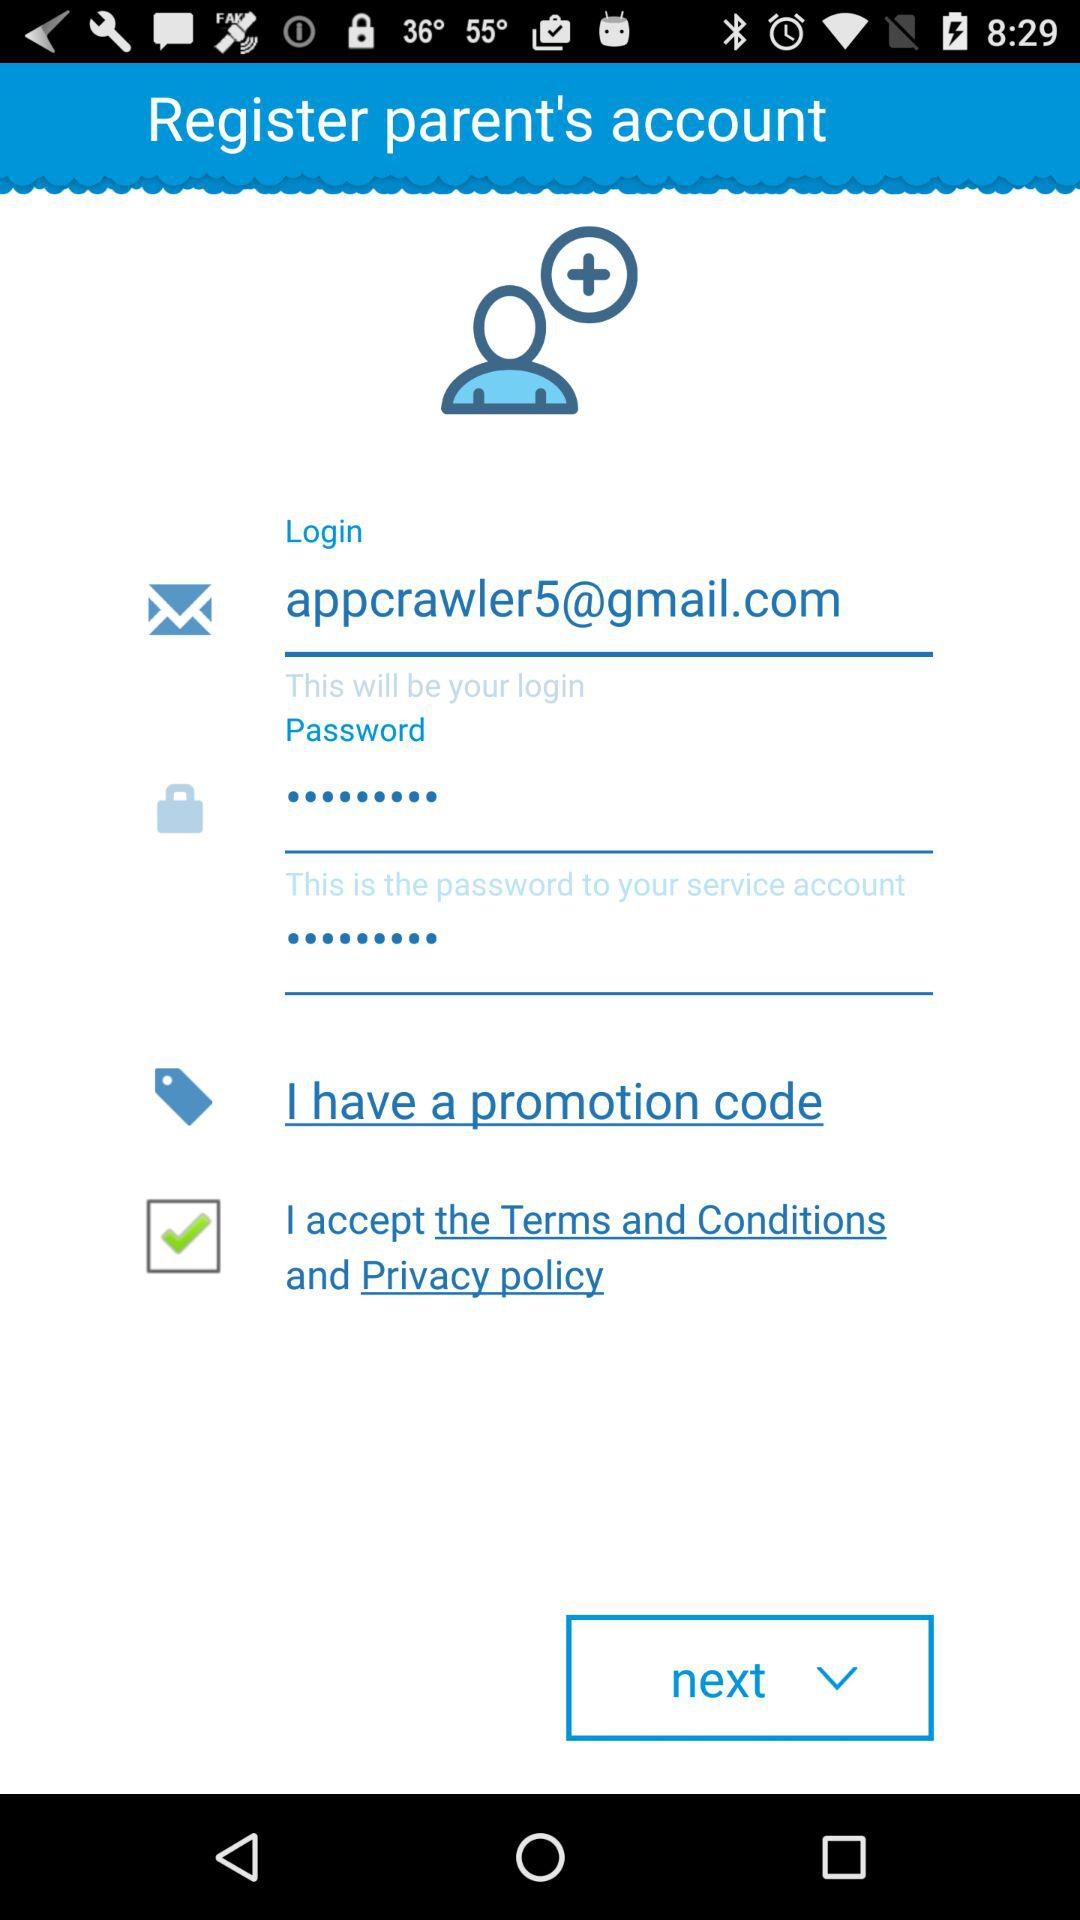What is the status of the option that includes acceptance of "the Terms and Conditions" and "Privacy policy"? The status is "on". 